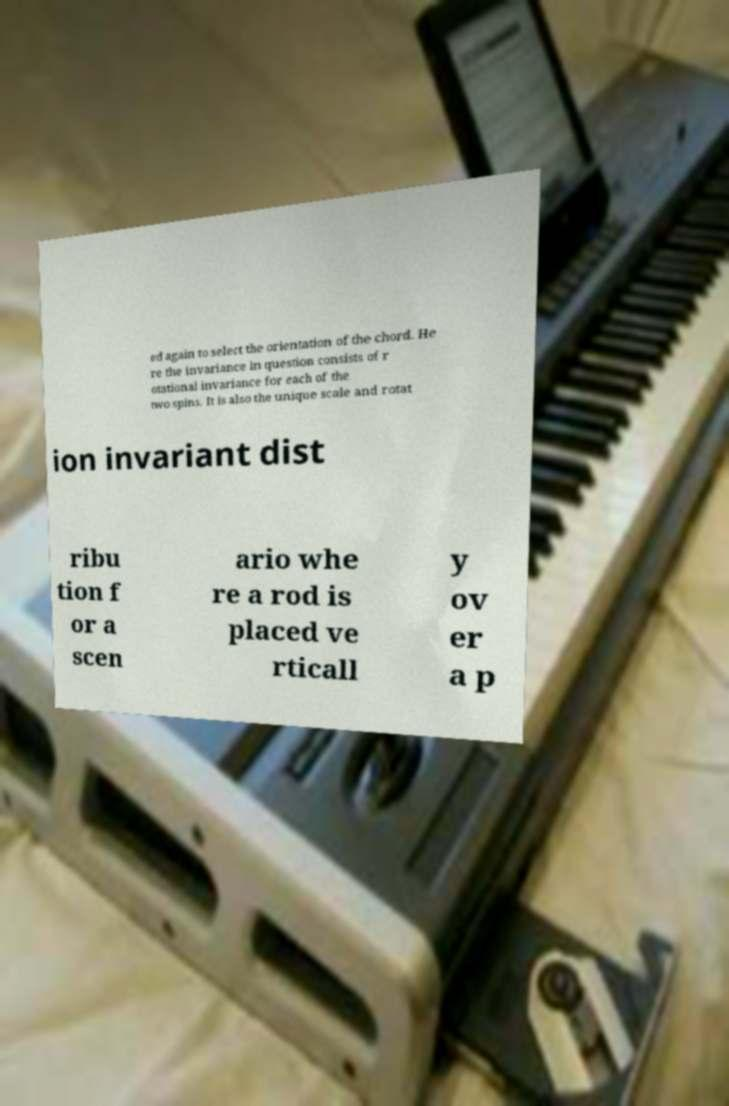Please identify and transcribe the text found in this image. ed again to select the orientation of the chord. He re the invariance in question consists of r otational invariance for each of the two spins. It is also the unique scale and rotat ion invariant dist ribu tion f or a scen ario whe re a rod is placed ve rticall y ov er a p 